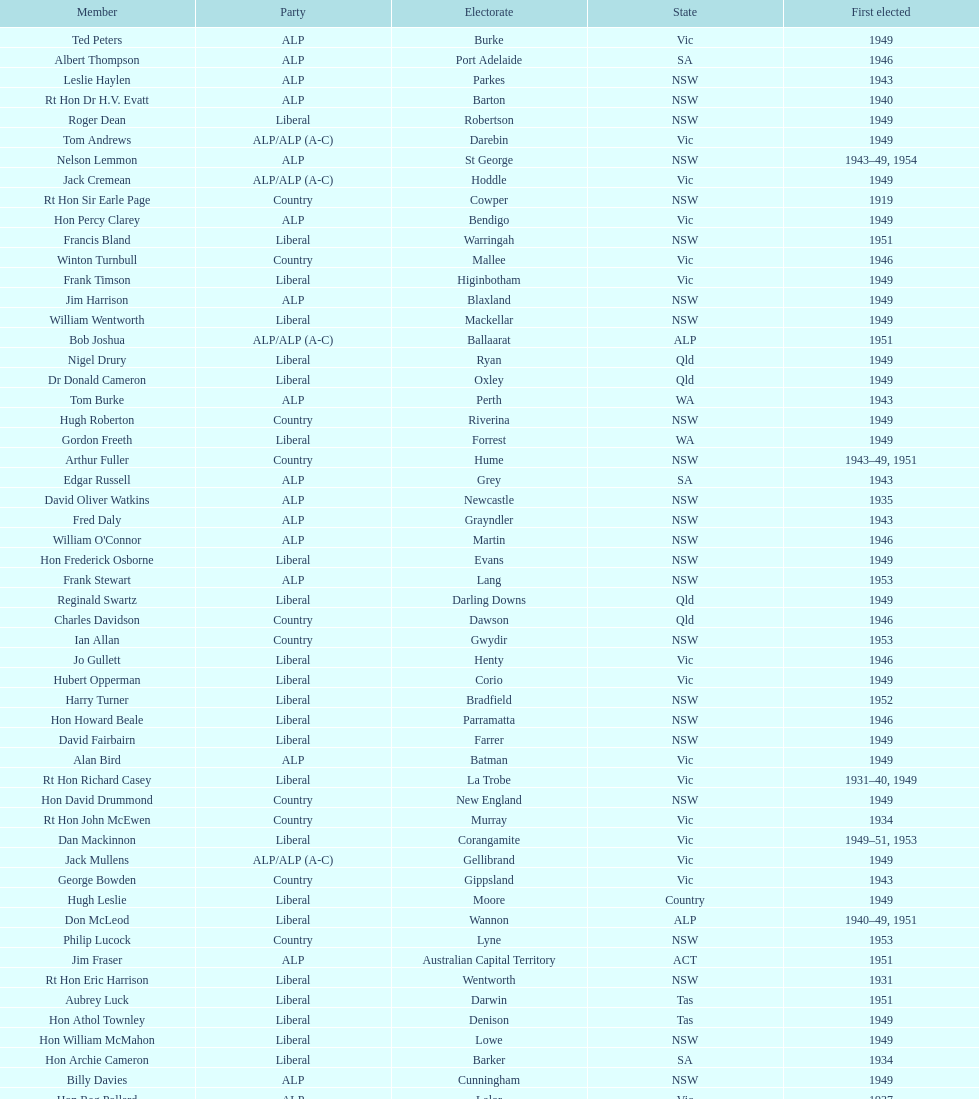After tom burke was elected, what was the next year where another tom would be elected? 1937. 